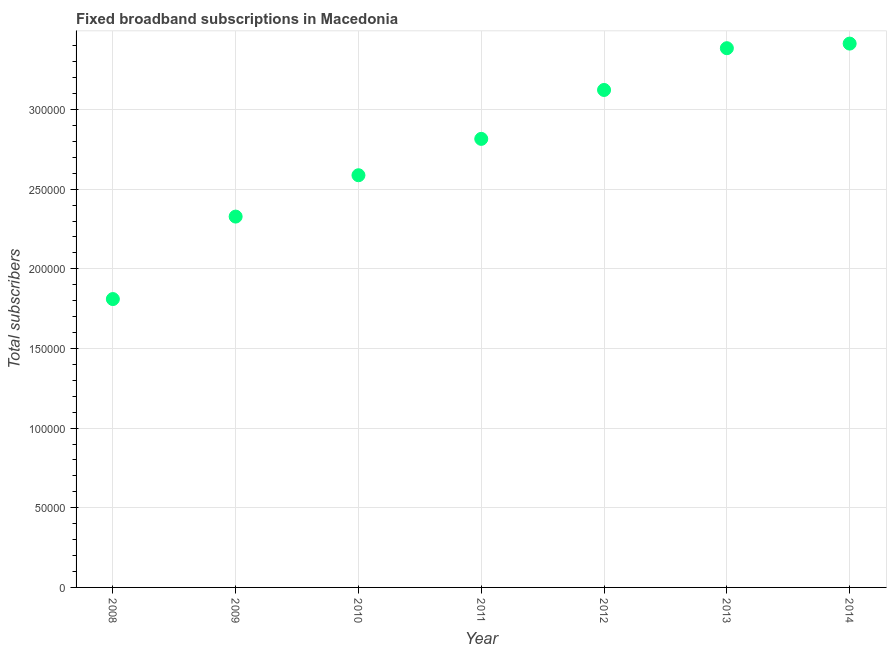What is the total number of fixed broadband subscriptions in 2010?
Your response must be concise. 2.59e+05. Across all years, what is the maximum total number of fixed broadband subscriptions?
Keep it short and to the point. 3.41e+05. Across all years, what is the minimum total number of fixed broadband subscriptions?
Give a very brief answer. 1.81e+05. In which year was the total number of fixed broadband subscriptions minimum?
Offer a terse response. 2008. What is the sum of the total number of fixed broadband subscriptions?
Provide a short and direct response. 1.95e+06. What is the difference between the total number of fixed broadband subscriptions in 2009 and 2012?
Your response must be concise. -7.95e+04. What is the average total number of fixed broadband subscriptions per year?
Your response must be concise. 2.78e+05. What is the median total number of fixed broadband subscriptions?
Offer a terse response. 2.82e+05. Do a majority of the years between 2009 and 2008 (inclusive) have total number of fixed broadband subscriptions greater than 140000 ?
Give a very brief answer. No. What is the ratio of the total number of fixed broadband subscriptions in 2008 to that in 2011?
Offer a very short reply. 0.64. What is the difference between the highest and the second highest total number of fixed broadband subscriptions?
Your response must be concise. 2887. Is the sum of the total number of fixed broadband subscriptions in 2009 and 2012 greater than the maximum total number of fixed broadband subscriptions across all years?
Offer a terse response. Yes. What is the difference between the highest and the lowest total number of fixed broadband subscriptions?
Keep it short and to the point. 1.60e+05. Does the total number of fixed broadband subscriptions monotonically increase over the years?
Your answer should be very brief. Yes. How many dotlines are there?
Provide a short and direct response. 1. How many years are there in the graph?
Your answer should be very brief. 7. Are the values on the major ticks of Y-axis written in scientific E-notation?
Offer a very short reply. No. What is the title of the graph?
Ensure brevity in your answer.  Fixed broadband subscriptions in Macedonia. What is the label or title of the Y-axis?
Keep it short and to the point. Total subscribers. What is the Total subscribers in 2008?
Give a very brief answer. 1.81e+05. What is the Total subscribers in 2009?
Your answer should be very brief. 2.33e+05. What is the Total subscribers in 2010?
Keep it short and to the point. 2.59e+05. What is the Total subscribers in 2011?
Offer a terse response. 2.82e+05. What is the Total subscribers in 2012?
Offer a terse response. 3.12e+05. What is the Total subscribers in 2013?
Your answer should be very brief. 3.38e+05. What is the Total subscribers in 2014?
Keep it short and to the point. 3.41e+05. What is the difference between the Total subscribers in 2008 and 2009?
Provide a short and direct response. -5.18e+04. What is the difference between the Total subscribers in 2008 and 2010?
Make the answer very short. -7.77e+04. What is the difference between the Total subscribers in 2008 and 2011?
Your answer should be compact. -1.01e+05. What is the difference between the Total subscribers in 2008 and 2012?
Give a very brief answer. -1.31e+05. What is the difference between the Total subscribers in 2008 and 2013?
Ensure brevity in your answer.  -1.57e+05. What is the difference between the Total subscribers in 2008 and 2014?
Offer a terse response. -1.60e+05. What is the difference between the Total subscribers in 2009 and 2010?
Your response must be concise. -2.60e+04. What is the difference between the Total subscribers in 2009 and 2011?
Offer a terse response. -4.88e+04. What is the difference between the Total subscribers in 2009 and 2012?
Your response must be concise. -7.95e+04. What is the difference between the Total subscribers in 2009 and 2013?
Give a very brief answer. -1.06e+05. What is the difference between the Total subscribers in 2009 and 2014?
Keep it short and to the point. -1.09e+05. What is the difference between the Total subscribers in 2010 and 2011?
Ensure brevity in your answer.  -2.28e+04. What is the difference between the Total subscribers in 2010 and 2012?
Make the answer very short. -5.35e+04. What is the difference between the Total subscribers in 2010 and 2013?
Your answer should be compact. -7.97e+04. What is the difference between the Total subscribers in 2010 and 2014?
Your answer should be compact. -8.26e+04. What is the difference between the Total subscribers in 2011 and 2012?
Give a very brief answer. -3.07e+04. What is the difference between the Total subscribers in 2011 and 2013?
Ensure brevity in your answer.  -5.69e+04. What is the difference between the Total subscribers in 2011 and 2014?
Provide a succinct answer. -5.98e+04. What is the difference between the Total subscribers in 2012 and 2013?
Your answer should be very brief. -2.62e+04. What is the difference between the Total subscribers in 2012 and 2014?
Offer a terse response. -2.91e+04. What is the difference between the Total subscribers in 2013 and 2014?
Ensure brevity in your answer.  -2887. What is the ratio of the Total subscribers in 2008 to that in 2009?
Your response must be concise. 0.78. What is the ratio of the Total subscribers in 2008 to that in 2010?
Your answer should be compact. 0.7. What is the ratio of the Total subscribers in 2008 to that in 2011?
Give a very brief answer. 0.64. What is the ratio of the Total subscribers in 2008 to that in 2012?
Provide a succinct answer. 0.58. What is the ratio of the Total subscribers in 2008 to that in 2013?
Your response must be concise. 0.54. What is the ratio of the Total subscribers in 2008 to that in 2014?
Your answer should be compact. 0.53. What is the ratio of the Total subscribers in 2009 to that in 2011?
Ensure brevity in your answer.  0.83. What is the ratio of the Total subscribers in 2009 to that in 2012?
Give a very brief answer. 0.74. What is the ratio of the Total subscribers in 2009 to that in 2013?
Give a very brief answer. 0.69. What is the ratio of the Total subscribers in 2009 to that in 2014?
Your answer should be compact. 0.68. What is the ratio of the Total subscribers in 2010 to that in 2011?
Your answer should be very brief. 0.92. What is the ratio of the Total subscribers in 2010 to that in 2012?
Make the answer very short. 0.83. What is the ratio of the Total subscribers in 2010 to that in 2013?
Ensure brevity in your answer.  0.76. What is the ratio of the Total subscribers in 2010 to that in 2014?
Provide a succinct answer. 0.76. What is the ratio of the Total subscribers in 2011 to that in 2012?
Keep it short and to the point. 0.9. What is the ratio of the Total subscribers in 2011 to that in 2013?
Give a very brief answer. 0.83. What is the ratio of the Total subscribers in 2011 to that in 2014?
Offer a terse response. 0.82. What is the ratio of the Total subscribers in 2012 to that in 2013?
Provide a short and direct response. 0.92. What is the ratio of the Total subscribers in 2012 to that in 2014?
Provide a short and direct response. 0.92. What is the ratio of the Total subscribers in 2013 to that in 2014?
Provide a short and direct response. 0.99. 